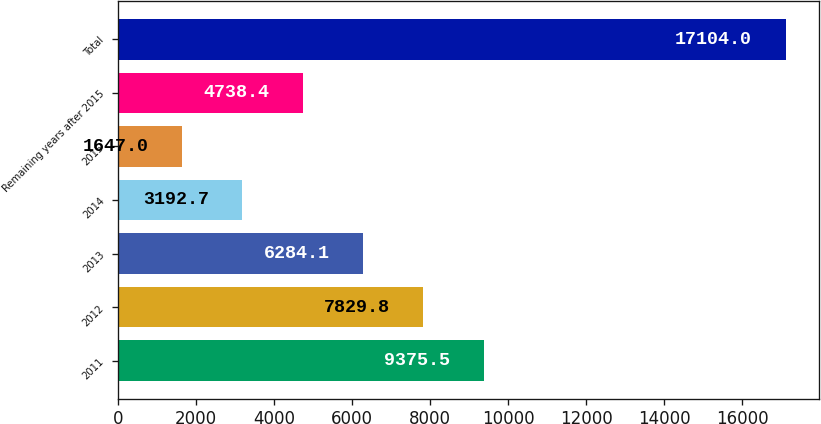<chart> <loc_0><loc_0><loc_500><loc_500><bar_chart><fcel>2011<fcel>2012<fcel>2013<fcel>2014<fcel>2015<fcel>Remaining years after 2015<fcel>Total<nl><fcel>9375.5<fcel>7829.8<fcel>6284.1<fcel>3192.7<fcel>1647<fcel>4738.4<fcel>17104<nl></chart> 